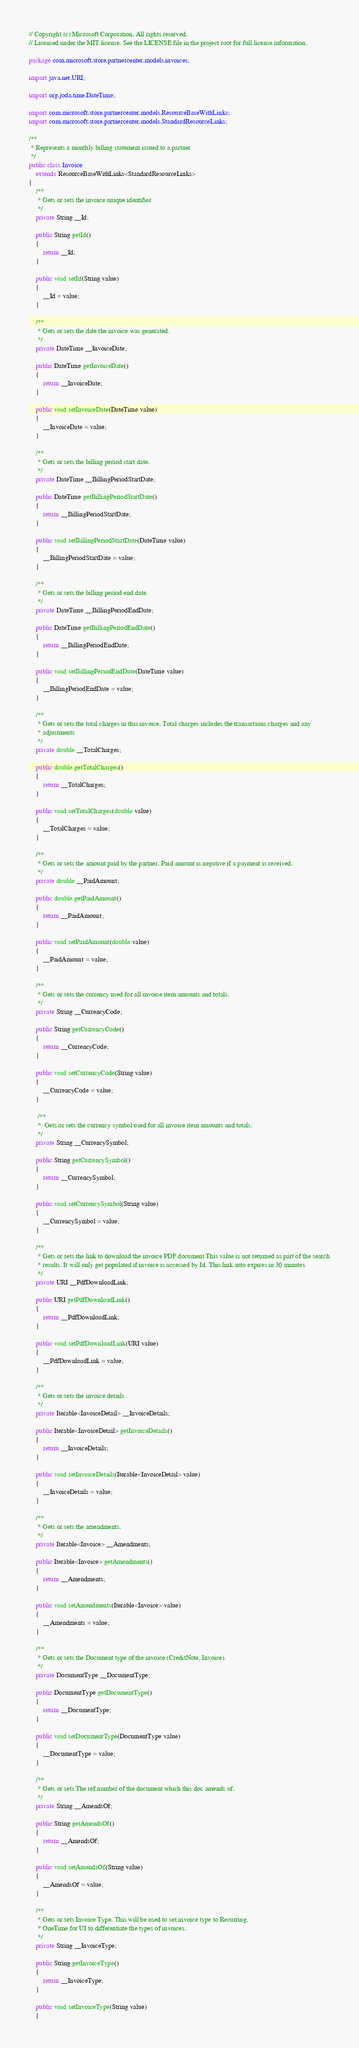<code> <loc_0><loc_0><loc_500><loc_500><_Java_>// Copyright (c) Microsoft Corporation. All rights reserved.
// Licensed under the MIT license. See the LICENSE file in the project root for full license information.

package com.microsoft.store.partnercenter.models.invoices;

import java.net.URI;

import org.joda.time.DateTime;

import com.microsoft.store.partnercenter.models.ResourceBaseWithLinks;
import com.microsoft.store.partnercenter.models.StandardResourceLinks;

/**
 * Represents a monthly billing statement issued to a partner
 */
public class Invoice
    extends ResourceBaseWithLinks<StandardResourceLinks>
{
    /**
     * Gets or sets the invoice unique identifier
     */
    private String __Id;

    public String getId()
    {
        return __Id;
    }

    public void setId(String value)
    {
        __Id = value;
    }

    /**
     * Gets or sets the date the invoice was generated.
     */
    private DateTime __InvoiceDate;

    public DateTime getInvoiceDate()
    {
        return __InvoiceDate;
    }

    public void setInvoiceDate(DateTime value)
    {
        __InvoiceDate = value;
    }

    /**
     * Gets or sets the billing period start date.
     */
    private DateTime __BillingPeriodStartDate;

    public DateTime getBillingPeriodStartDate()
    {
        return __BillingPeriodStartDate;
    }

    public void setBillingPeriodStartDate(DateTime value)
    {
        __BillingPeriodStartDate = value;
    }

    /**
     * Gets or sets the billing period end date.
     */
    private DateTime __BillingPeriodEndDate;

    public DateTime getBillingPeriodEndDate()
    {
        return __BillingPeriodEndDate;
    }

    public void setBillingPeriodEndDate(DateTime value)
    {
        __BillingPeriodEndDate = value;
    }

    /**
     * Gets or sets the total charges in this invoice. Total charges includes the transactions charges and any
     * adjustments
     */
    private double __TotalCharges;

    public double getTotalCharges()
    {
        return __TotalCharges;
    }

    public void setTotalCharges(double value)
    {
        __TotalCharges = value;
    }

    /**
     * Gets or sets the amount paid by the partner. Paid amount is negative if a payment is received.
     */
    private double __PaidAmount;

    public double getPaidAmount()
    {
        return __PaidAmount;
    }

    public void setPaidAmount(double value)
    {
        __PaidAmount = value;
    }

    /**
     * Gets or sets the currency used for all invoice item amounts and totals.
     */
    private String __CurrencyCode;

    public String getCurrencyCode()
    {
        return __CurrencyCode;
    }

    public void setCurrencyCode(String value)
    {
        __CurrencyCode = value;
    }

     /**
     *  Gets or sets the currency symbol used for all invoice item amounts and totals.
     */
    private String __CurrencySymbol;

    public String getCurrencySymbol()
    {
        return __CurrencySymbol;
    }

    public void setCurrencySymbol(String value)
    {
        __CurrencySymbol = value;
    }

    /**
     * Gets or sets the link to download the invoice PDF document This value is not returned as part of the search
     * results. It will only get populated if invoice is accessed by Id. This link auto expires in 30 minutes
     */
    private URI __PdfDownloadLink;

    public URI getPdfDownloadLink()
    {
        return __PdfDownloadLink;
    }

    public void setPdfDownloadLink(URI value)
    {
        __PdfDownloadLink = value;
    }

    /**
     * Gets or sets the invoice details
     */
    private Iterable<InvoiceDetail> __InvoiceDetails;

    public Iterable<InvoiceDetail> getInvoiceDetails()
    {
        return __InvoiceDetails;
    }

    public void setInvoiceDetails(Iterable<InvoiceDetail> value)
    {
        __InvoiceDetails = value;
    }

    /**
     * Gets or sets the amendments.
     */
    private Iterable<Invoice> __Amendments;

    public Iterable<Invoice> getAmendments()
    {
        return __Amendments;
    }

    public void setAmendments(Iterable<Invoice> value)
    {
        __Amendments = value;
    }

    /**
     * Gets or sets the Document type of the invoice (CreditNote, Invoice).
     */
    private DocumentType __DocumentType;

    public DocumentType getDocumentType()
    {
        return __DocumentType;
    }

    public void setDocumentType(DocumentType value)
    {
        __DocumentType = value;
    }

    /**
     * Gets or sets The ref number of the document which this doc amends of.
     */
    private String __AmendsOf;

    public String getAmendsOf()
    {
        return __AmendsOf;
    }

    public void setAmendsOf(String value)
    {
        __AmendsOf = value;
    }

    /**
     * Gets or sets Invoice Type. This will be used to set invoice type to Recurring,
     * OneTime for UI to differentiate the types of invoices.
     */
    private String __InvoiceType;

    public String getInvoiceType()
    {
        return __InvoiceType;
    }

    public void setInvoiceType(String value)
    {</code> 